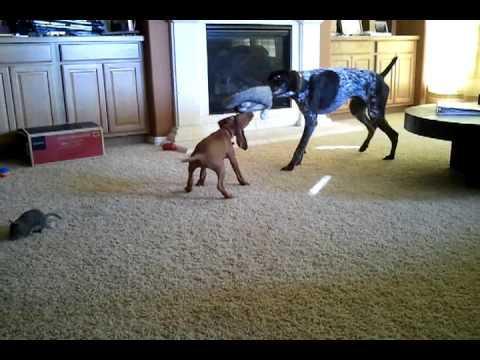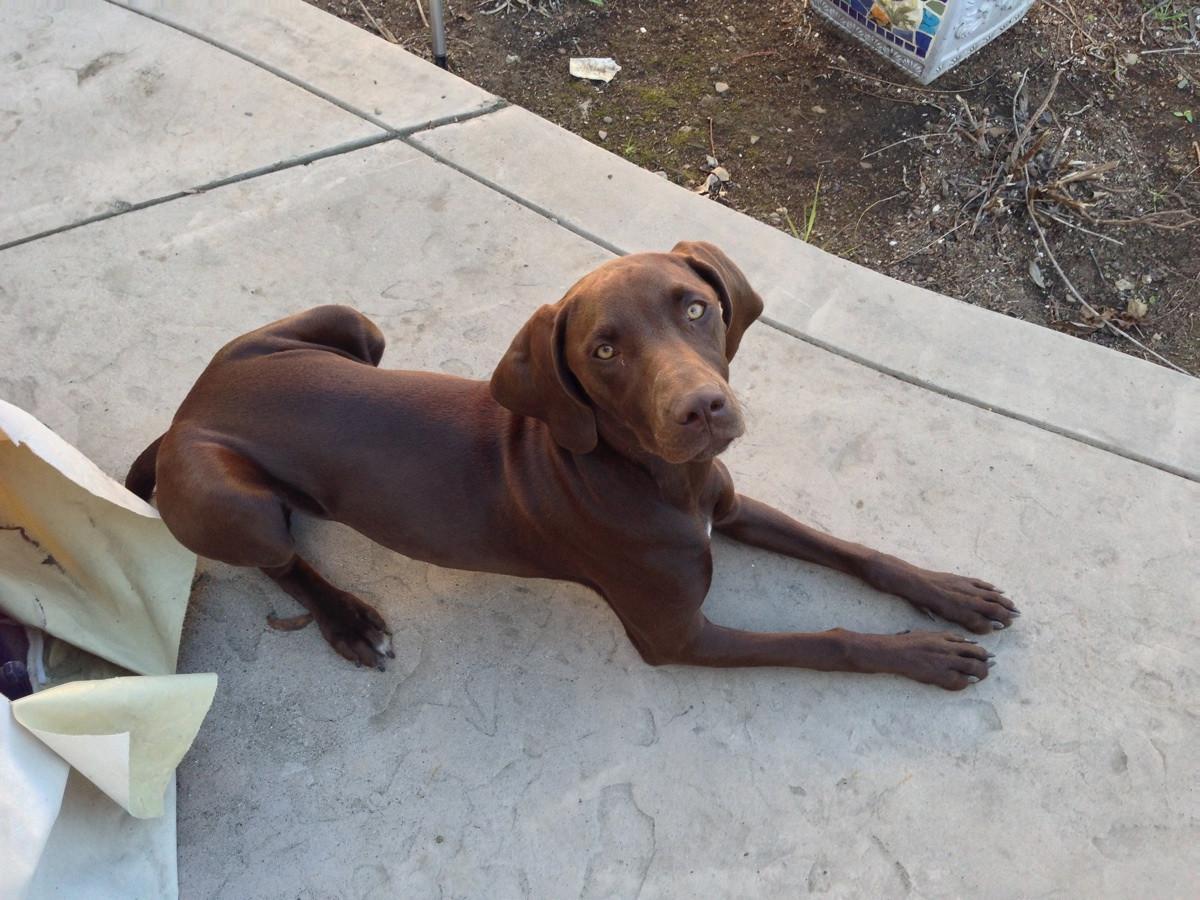The first image is the image on the left, the second image is the image on the right. Examine the images to the left and right. Is the description "One image shows a single dog, which has short reddish-orange fur and is standing on an elevated platform with its body turned forward." accurate? Answer yes or no. No. The first image is the image on the left, the second image is the image on the right. For the images shown, is this caption "There are exactly two live dogs." true? Answer yes or no. No. 